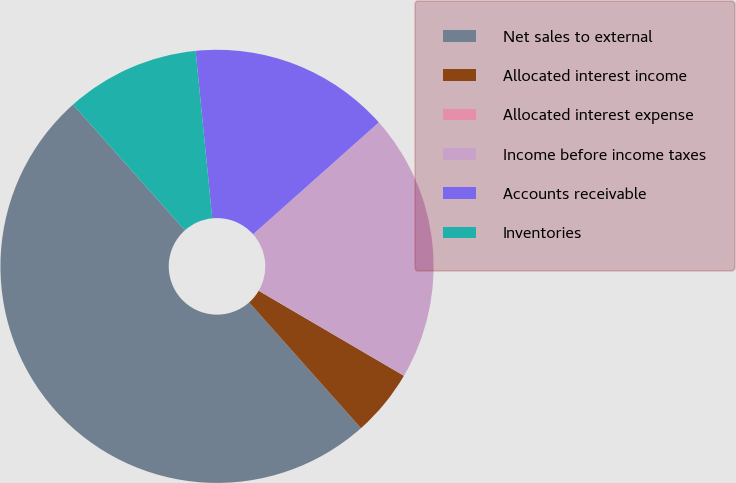Convert chart to OTSL. <chart><loc_0><loc_0><loc_500><loc_500><pie_chart><fcel>Net sales to external<fcel>Allocated interest income<fcel>Allocated interest expense<fcel>Income before income taxes<fcel>Accounts receivable<fcel>Inventories<nl><fcel>49.99%<fcel>5.0%<fcel>0.0%<fcel>20.0%<fcel>15.0%<fcel>10.0%<nl></chart> 